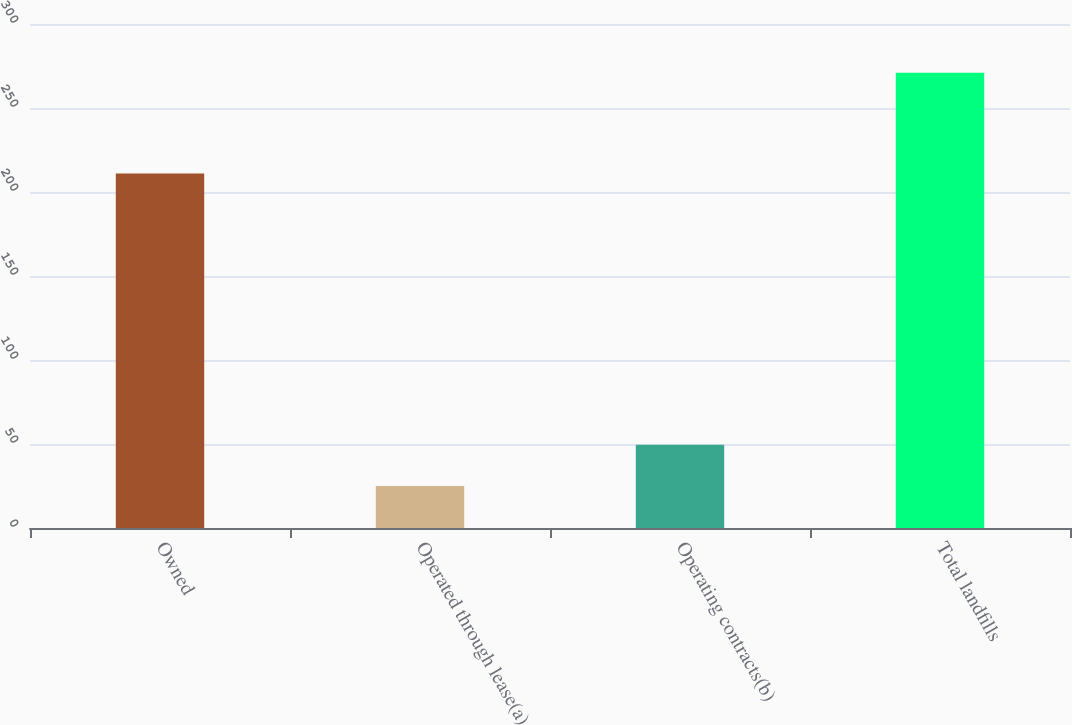<chart> <loc_0><loc_0><loc_500><loc_500><bar_chart><fcel>Owned<fcel>Operated through lease(a)<fcel>Operating contracts(b)<fcel>Total landfills<nl><fcel>211<fcel>25<fcel>49.6<fcel>271<nl></chart> 